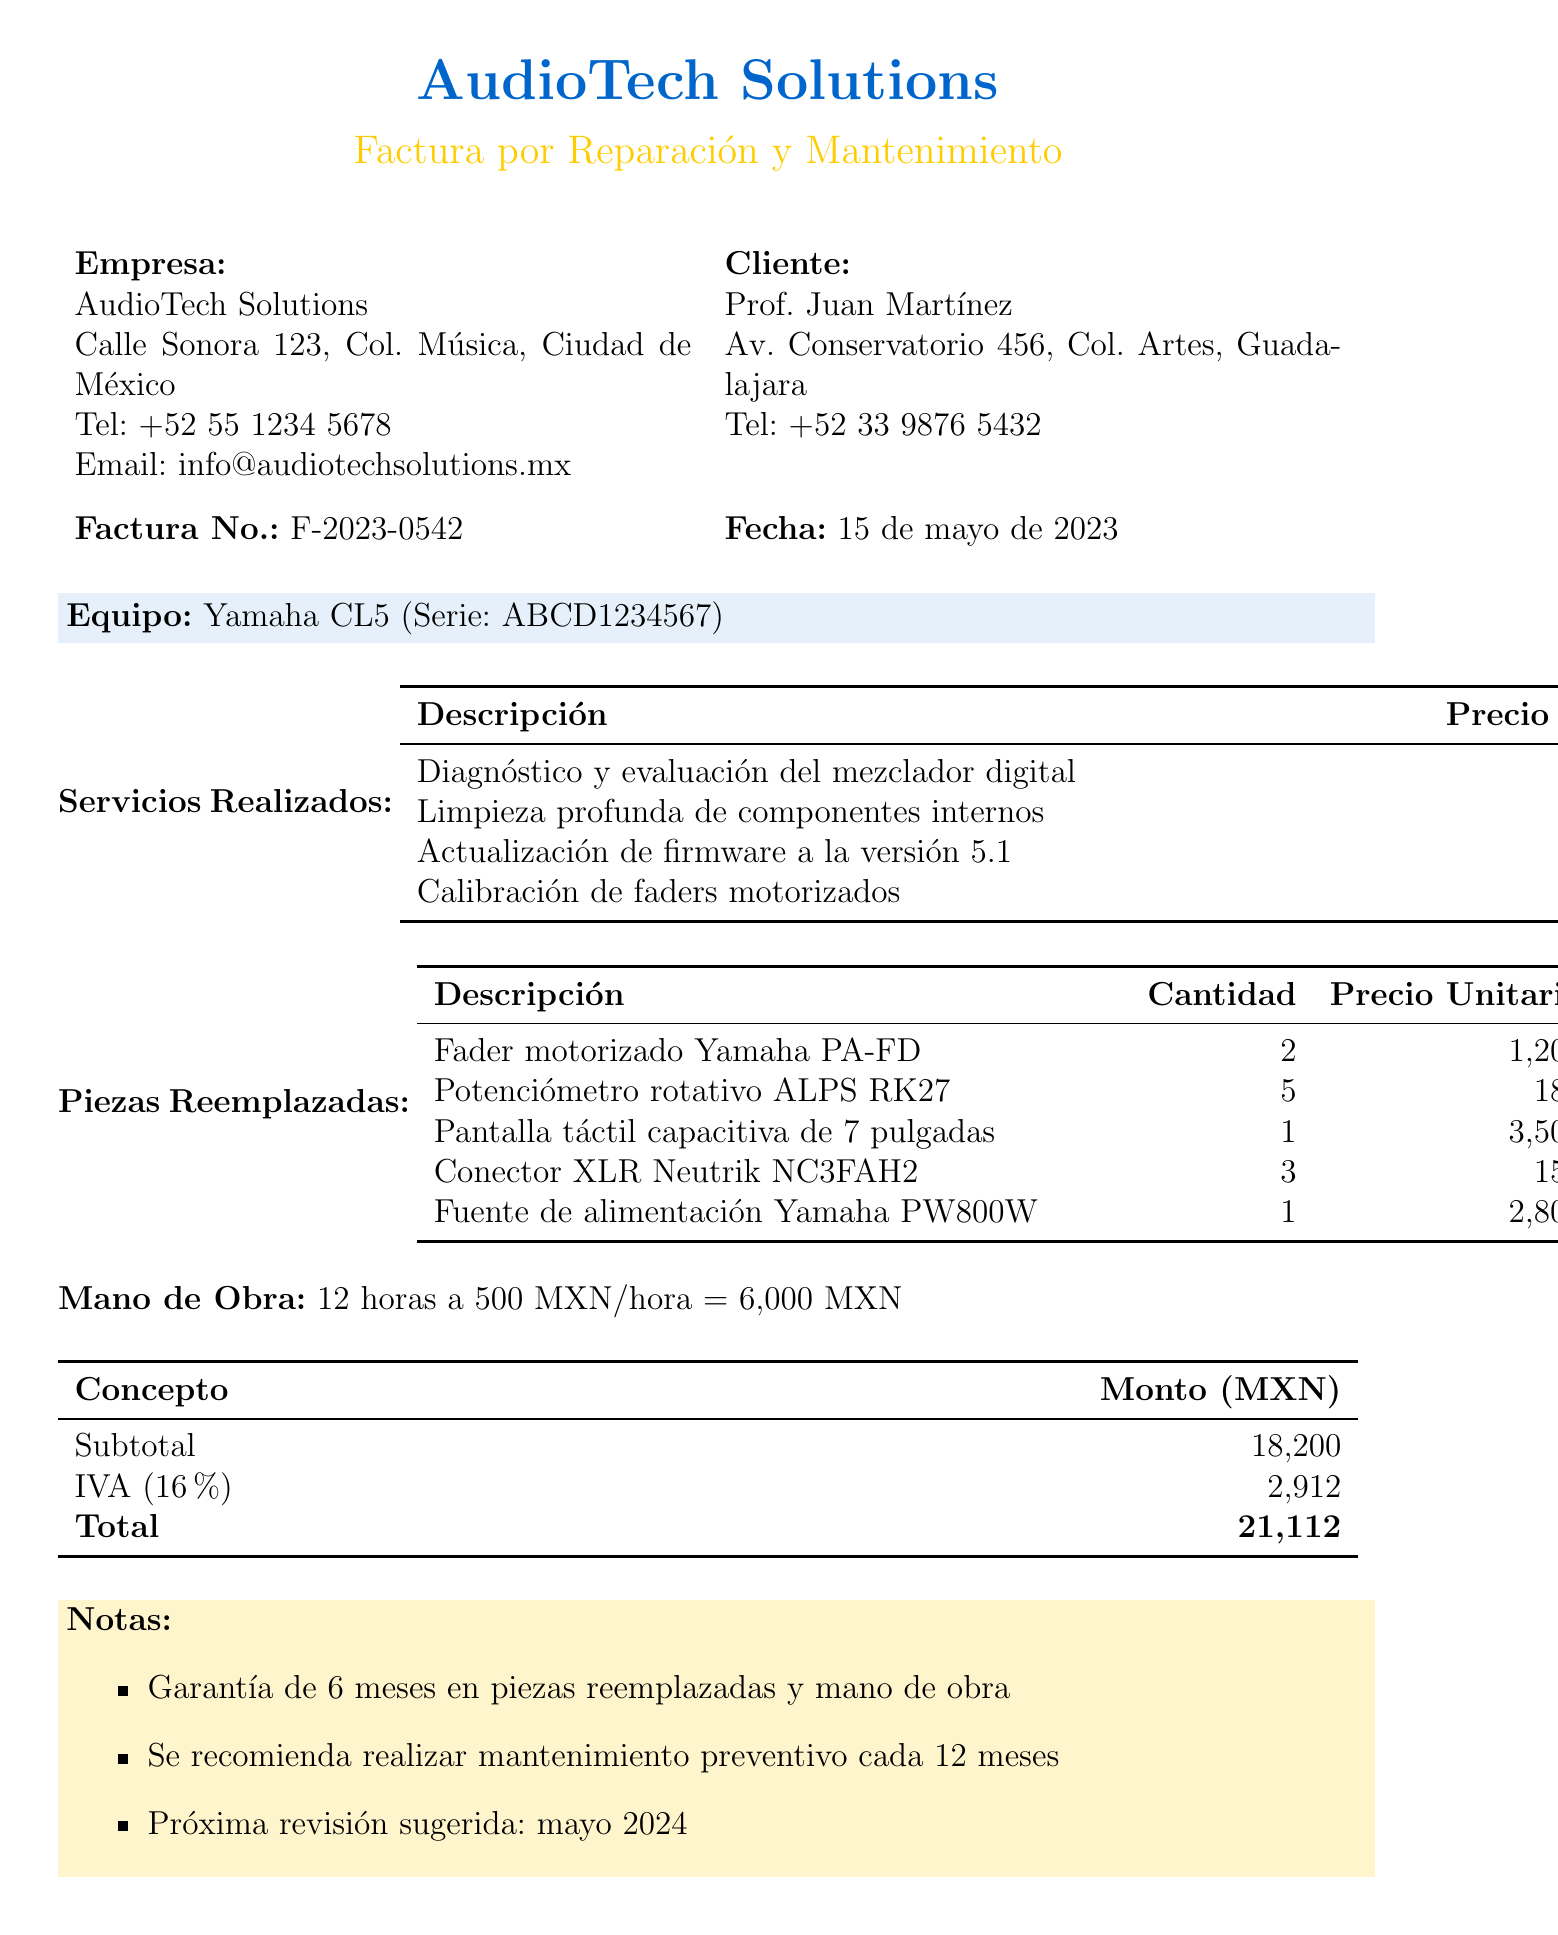¿Qué es lo que se factura? El documento especifica que se factura por la reparación y mantenimiento de un mezclador de audio digital.
Answer: Reparación y mantenimiento de un mezclador de audio digital ¿Cuál es el número de la factura? El número de la factura se menciona claramente en el documento como F-2023-0542.
Answer: F-2023-0542 ¿Cuál es el total de la factura? El documento detalla que el total de la factura es de 21,112 pesos mexicanos.
Answer: 21,112 ¿Cuál es la garantía ofrecida? Se menciona en las notas que hay una garantía de 6 meses en piezas reemplazadas y mano de obra.
Answer: 6 meses ¿Cuántas horas de mano de obra se facturaron? El documento indica que se facturaron 12 horas de mano de obra.
Answer: 12 horas ¿Qué piezas fueron reemplazadas en el servicio? La lista de piezas reemplazadas está detallada en el documento e incluye varios componentes como faders y potenciómetros.
Answer: Fader motorizado, Potenciómetro rotativo, Pantalla táctil, Conector XLR, Fuente de alimentación ¿Cuál es el banco para la transferencia bancaria? El documento especifica que el banco para la transferencia es BBVA.
Answer: BBVA ¿Cuál es la próxima revisión sugerida? Se indica en las notas que la próxima revisión sugerida es en mayo de 2024.
Answer: Mayo 2024 